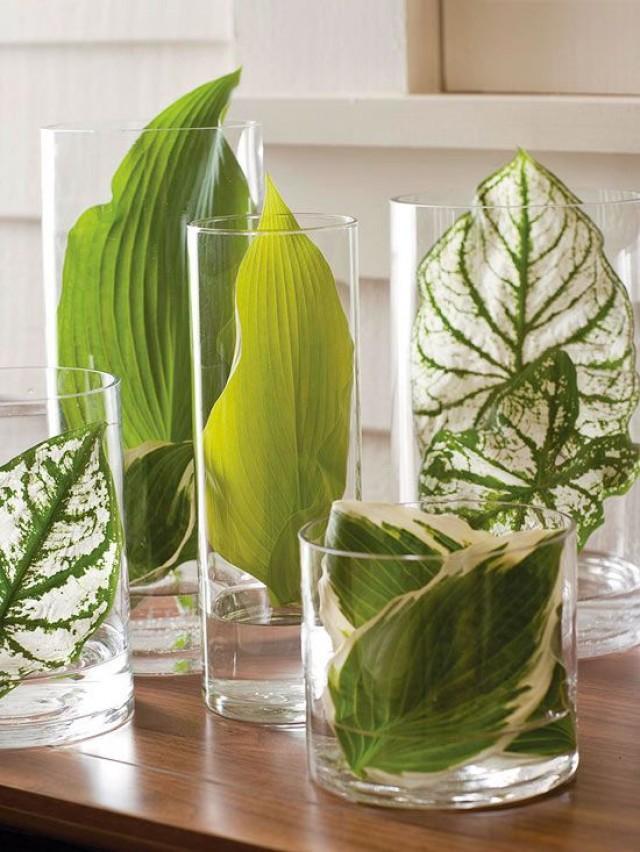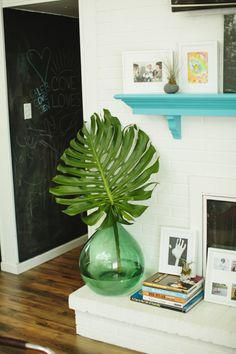The first image is the image on the left, the second image is the image on the right. Given the left and right images, does the statement "At least one of the images shows one or more candles next to a plant." hold true? Answer yes or no. No. The first image is the image on the left, the second image is the image on the right. Given the left and right images, does the statement "In one of the image there is vase with a plant in it in front of a window." hold true? Answer yes or no. No. 